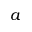Convert formula to latex. <formula><loc_0><loc_0><loc_500><loc_500>a</formula> 